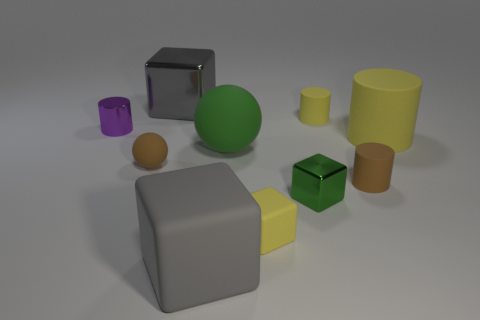Can you guess which object might weigh the most? If we assume the objects are made from typical materials, the shiny, metallic cube likely weighs the most due to the density of metal compared to plastic or rubber. 